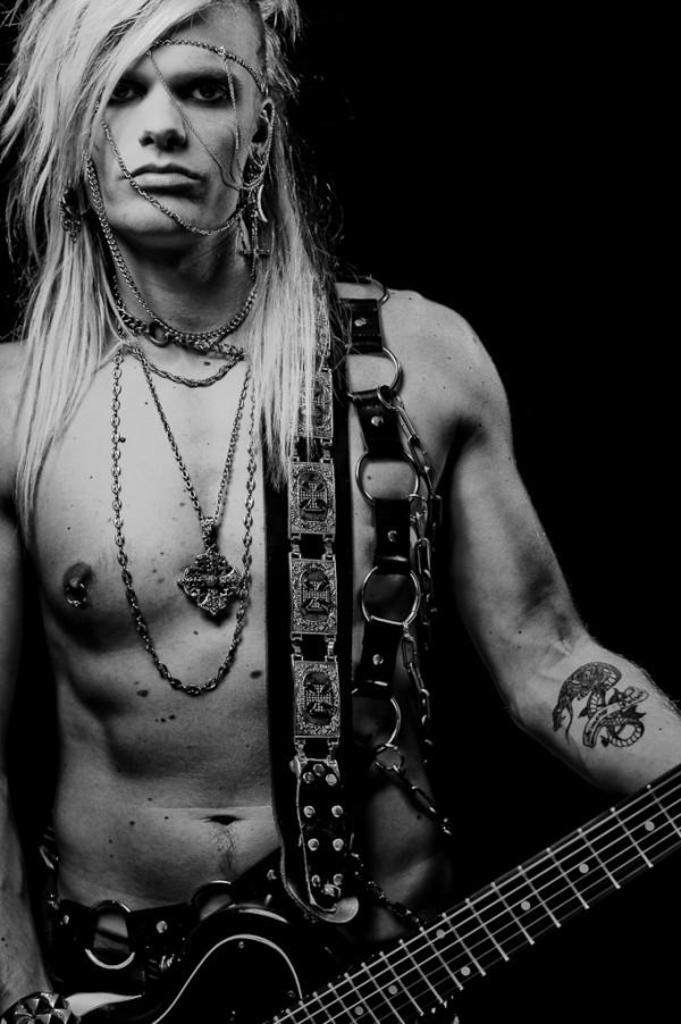What is the man in the image holding? The man is holding a guitar in the image. Can you describe any visible accessories or body art on the man? The man has a tattoo on his hand and is wearing chains around his neck. What type of beetle can be seen crawling on the man's dad in the image? There is no dad or beetle present in the image; it only features a man holding a guitar and wearing chains around his neck. 